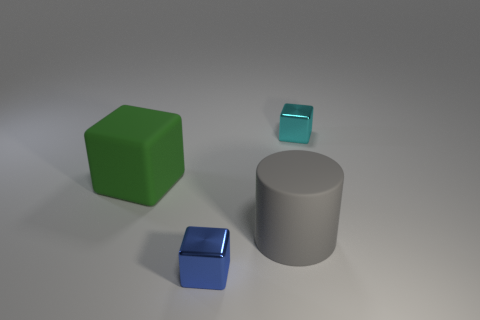Subtract all metallic blocks. How many blocks are left? 1 Add 3 matte things. How many objects exist? 7 Subtract all cylinders. How many objects are left? 3 Subtract all gray blocks. Subtract all cyan cylinders. How many blocks are left? 3 Add 3 green cubes. How many green cubes exist? 4 Subtract 0 purple spheres. How many objects are left? 4 Subtract all big gray things. Subtract all small blue cubes. How many objects are left? 2 Add 4 cylinders. How many cylinders are left? 5 